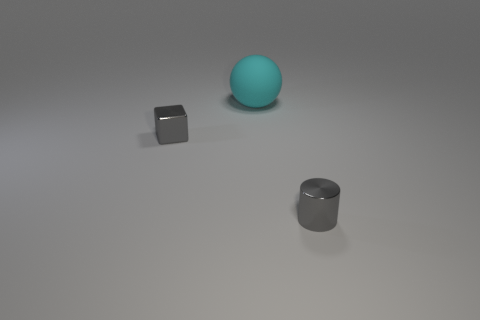Is the tiny gray cylinder made of the same material as the tiny gray block?
Provide a short and direct response. Yes. Are there any things that are behind the small gray thing behind the small cylinder?
Offer a terse response. Yes. How many tiny objects are both to the right of the cyan rubber thing and to the left of the cyan object?
Provide a succinct answer. 0. There is a object that is in front of the gray metal cube; what is its shape?
Ensure brevity in your answer.  Cylinder. What number of objects are the same size as the gray metal cube?
Provide a succinct answer. 1. There is a small thing behind the small metal cylinder; is it the same color as the small shiny cylinder?
Give a very brief answer. Yes. The object that is left of the cylinder and in front of the big cyan sphere is made of what material?
Offer a very short reply. Metal. Are there more metallic things than large green rubber cylinders?
Offer a very short reply. Yes. There is a ball that is to the right of the metallic object that is on the left side of the metal thing that is in front of the tiny gray block; what is its color?
Make the answer very short. Cyan. Are the tiny gray object that is right of the big cyan thing and the big cyan thing made of the same material?
Provide a short and direct response. No. 